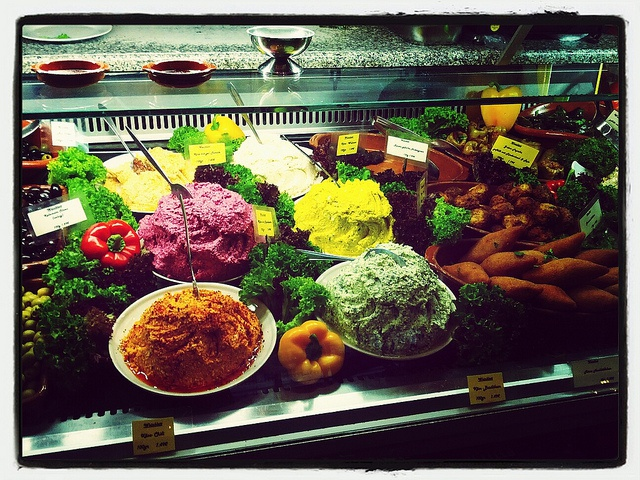Describe the objects in this image and their specific colors. I can see bowl in white, maroon, black, khaki, and darkgreen tones, bowl in white, maroon, lightpink, pink, and brown tones, broccoli in white, black, darkgreen, and green tones, bowl in white, maroon, black, lightyellow, and brown tones, and bowl in white, black, maroon, gray, and olive tones in this image. 